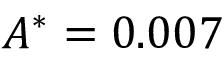<formula> <loc_0><loc_0><loc_500><loc_500>A ^ { * } = 0 . 0 0 7</formula> 